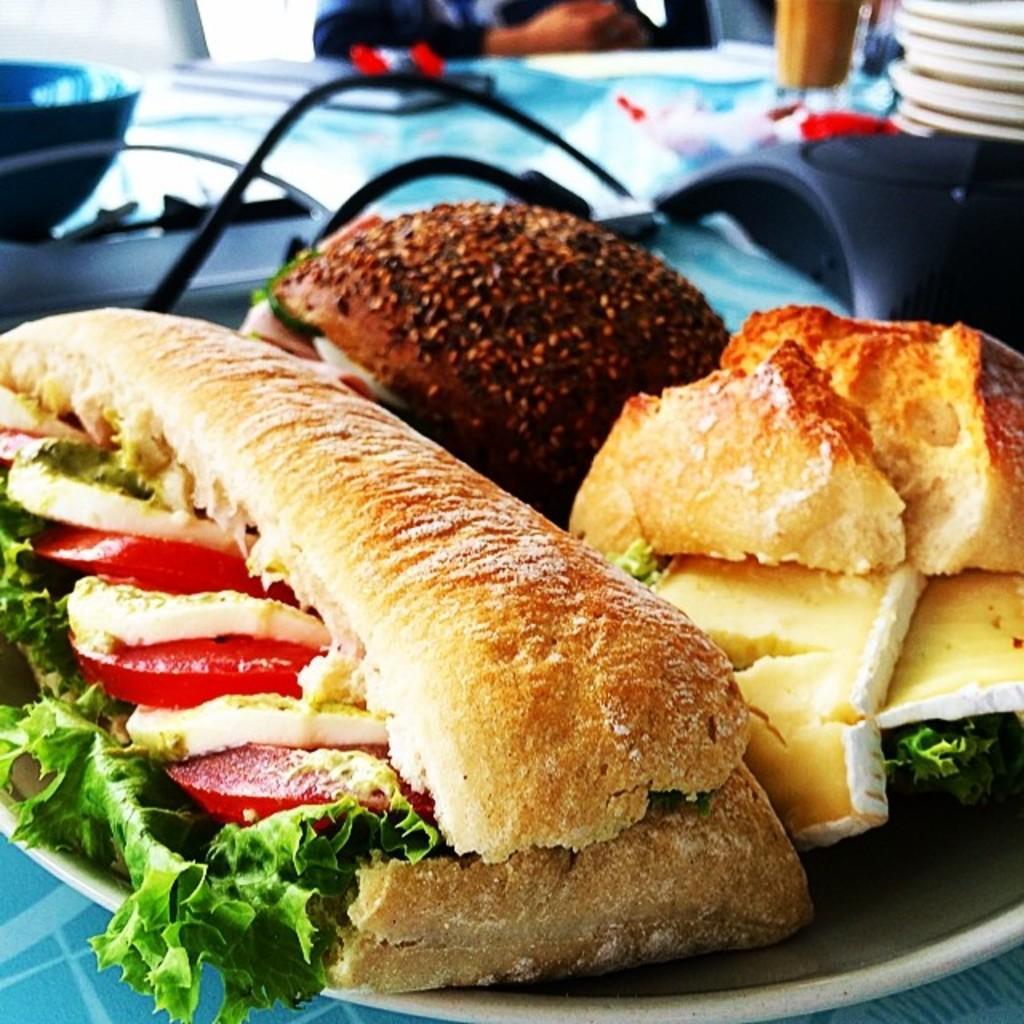Describe this image in one or two sentences. In this picture, there are different varieties of burger on the plate. 